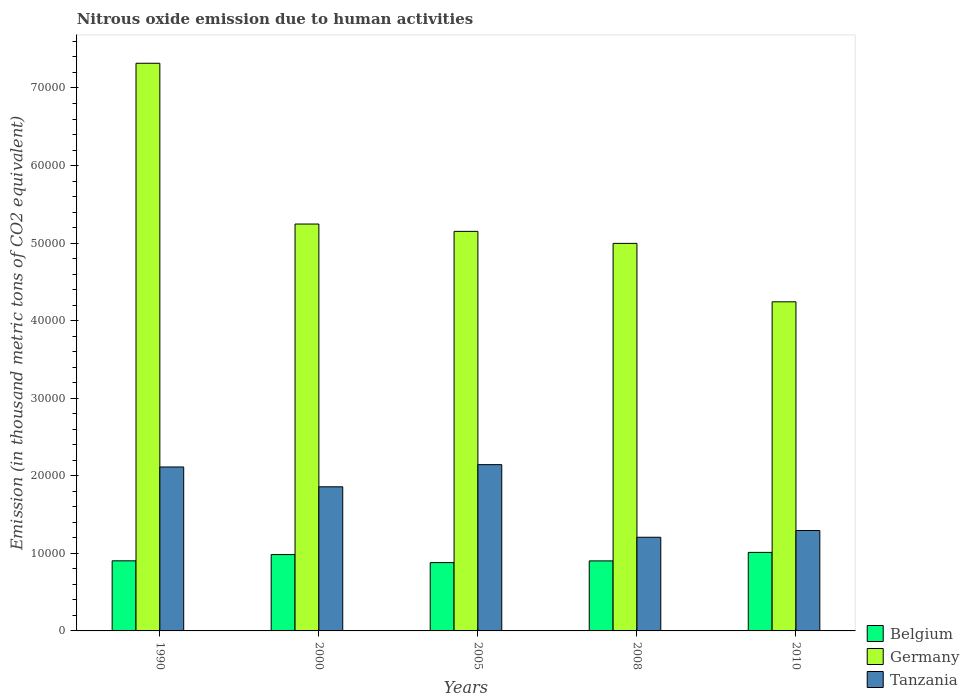How many different coloured bars are there?
Ensure brevity in your answer.  3. How many groups of bars are there?
Make the answer very short. 5. Are the number of bars per tick equal to the number of legend labels?
Give a very brief answer. Yes. Are the number of bars on each tick of the X-axis equal?
Make the answer very short. Yes. How many bars are there on the 3rd tick from the left?
Offer a terse response. 3. How many bars are there on the 2nd tick from the right?
Your answer should be compact. 3. What is the label of the 4th group of bars from the left?
Make the answer very short. 2008. In how many cases, is the number of bars for a given year not equal to the number of legend labels?
Your response must be concise. 0. What is the amount of nitrous oxide emitted in Tanzania in 1990?
Your answer should be very brief. 2.11e+04. Across all years, what is the maximum amount of nitrous oxide emitted in Belgium?
Keep it short and to the point. 1.01e+04. Across all years, what is the minimum amount of nitrous oxide emitted in Belgium?
Give a very brief answer. 8808.6. In which year was the amount of nitrous oxide emitted in Belgium maximum?
Give a very brief answer. 2010. In which year was the amount of nitrous oxide emitted in Germany minimum?
Ensure brevity in your answer.  2010. What is the total amount of nitrous oxide emitted in Germany in the graph?
Offer a terse response. 2.70e+05. What is the difference between the amount of nitrous oxide emitted in Tanzania in 2000 and that in 2008?
Offer a very short reply. 6504.6. What is the difference between the amount of nitrous oxide emitted in Belgium in 2000 and the amount of nitrous oxide emitted in Germany in 2008?
Your answer should be compact. -4.01e+04. What is the average amount of nitrous oxide emitted in Belgium per year?
Keep it short and to the point. 9369.18. In the year 2008, what is the difference between the amount of nitrous oxide emitted in Germany and amount of nitrous oxide emitted in Tanzania?
Your response must be concise. 3.79e+04. In how many years, is the amount of nitrous oxide emitted in Germany greater than 44000 thousand metric tons?
Offer a very short reply. 4. What is the ratio of the amount of nitrous oxide emitted in Tanzania in 2005 to that in 2008?
Provide a short and direct response. 1.78. Is the amount of nitrous oxide emitted in Germany in 1990 less than that in 2005?
Your response must be concise. No. What is the difference between the highest and the second highest amount of nitrous oxide emitted in Germany?
Provide a succinct answer. 2.07e+04. What is the difference between the highest and the lowest amount of nitrous oxide emitted in Tanzania?
Offer a very short reply. 9361.8. In how many years, is the amount of nitrous oxide emitted in Tanzania greater than the average amount of nitrous oxide emitted in Tanzania taken over all years?
Offer a very short reply. 3. Is the sum of the amount of nitrous oxide emitted in Tanzania in 2000 and 2005 greater than the maximum amount of nitrous oxide emitted in Belgium across all years?
Keep it short and to the point. Yes. What does the 1st bar from the right in 2010 represents?
Your answer should be compact. Tanzania. How many bars are there?
Offer a terse response. 15. Are all the bars in the graph horizontal?
Provide a succinct answer. No. How many years are there in the graph?
Offer a terse response. 5. Are the values on the major ticks of Y-axis written in scientific E-notation?
Your response must be concise. No. Where does the legend appear in the graph?
Your answer should be very brief. Bottom right. How many legend labels are there?
Offer a terse response. 3. What is the title of the graph?
Your response must be concise. Nitrous oxide emission due to human activities. Does "Liechtenstein" appear as one of the legend labels in the graph?
Give a very brief answer. No. What is the label or title of the Y-axis?
Your response must be concise. Emission (in thousand metric tons of CO2 equivalent). What is the Emission (in thousand metric tons of CO2 equivalent) of Belgium in 1990?
Keep it short and to the point. 9037.7. What is the Emission (in thousand metric tons of CO2 equivalent) of Germany in 1990?
Keep it short and to the point. 7.32e+04. What is the Emission (in thousand metric tons of CO2 equivalent) in Tanzania in 1990?
Keep it short and to the point. 2.11e+04. What is the Emission (in thousand metric tons of CO2 equivalent) of Belgium in 2000?
Offer a very short reply. 9844.1. What is the Emission (in thousand metric tons of CO2 equivalent) in Germany in 2000?
Ensure brevity in your answer.  5.25e+04. What is the Emission (in thousand metric tons of CO2 equivalent) of Tanzania in 2000?
Offer a very short reply. 1.86e+04. What is the Emission (in thousand metric tons of CO2 equivalent) in Belgium in 2005?
Keep it short and to the point. 8808.6. What is the Emission (in thousand metric tons of CO2 equivalent) in Germany in 2005?
Make the answer very short. 5.15e+04. What is the Emission (in thousand metric tons of CO2 equivalent) of Tanzania in 2005?
Keep it short and to the point. 2.14e+04. What is the Emission (in thousand metric tons of CO2 equivalent) in Belgium in 2008?
Offer a very short reply. 9028.7. What is the Emission (in thousand metric tons of CO2 equivalent) of Germany in 2008?
Give a very brief answer. 5.00e+04. What is the Emission (in thousand metric tons of CO2 equivalent) of Tanzania in 2008?
Make the answer very short. 1.21e+04. What is the Emission (in thousand metric tons of CO2 equivalent) in Belgium in 2010?
Give a very brief answer. 1.01e+04. What is the Emission (in thousand metric tons of CO2 equivalent) of Germany in 2010?
Keep it short and to the point. 4.24e+04. What is the Emission (in thousand metric tons of CO2 equivalent) of Tanzania in 2010?
Your answer should be compact. 1.29e+04. Across all years, what is the maximum Emission (in thousand metric tons of CO2 equivalent) of Belgium?
Ensure brevity in your answer.  1.01e+04. Across all years, what is the maximum Emission (in thousand metric tons of CO2 equivalent) in Germany?
Ensure brevity in your answer.  7.32e+04. Across all years, what is the maximum Emission (in thousand metric tons of CO2 equivalent) of Tanzania?
Offer a very short reply. 2.14e+04. Across all years, what is the minimum Emission (in thousand metric tons of CO2 equivalent) of Belgium?
Your answer should be very brief. 8808.6. Across all years, what is the minimum Emission (in thousand metric tons of CO2 equivalent) of Germany?
Your answer should be very brief. 4.24e+04. Across all years, what is the minimum Emission (in thousand metric tons of CO2 equivalent) in Tanzania?
Keep it short and to the point. 1.21e+04. What is the total Emission (in thousand metric tons of CO2 equivalent) of Belgium in the graph?
Your answer should be very brief. 4.68e+04. What is the total Emission (in thousand metric tons of CO2 equivalent) of Germany in the graph?
Your answer should be compact. 2.70e+05. What is the total Emission (in thousand metric tons of CO2 equivalent) in Tanzania in the graph?
Your response must be concise. 8.62e+04. What is the difference between the Emission (in thousand metric tons of CO2 equivalent) in Belgium in 1990 and that in 2000?
Your answer should be compact. -806.4. What is the difference between the Emission (in thousand metric tons of CO2 equivalent) in Germany in 1990 and that in 2000?
Your answer should be compact. 2.07e+04. What is the difference between the Emission (in thousand metric tons of CO2 equivalent) of Tanzania in 1990 and that in 2000?
Your answer should be very brief. 2557. What is the difference between the Emission (in thousand metric tons of CO2 equivalent) in Belgium in 1990 and that in 2005?
Offer a very short reply. 229.1. What is the difference between the Emission (in thousand metric tons of CO2 equivalent) of Germany in 1990 and that in 2005?
Offer a very short reply. 2.17e+04. What is the difference between the Emission (in thousand metric tons of CO2 equivalent) in Tanzania in 1990 and that in 2005?
Your answer should be compact. -300.2. What is the difference between the Emission (in thousand metric tons of CO2 equivalent) in Belgium in 1990 and that in 2008?
Make the answer very short. 9. What is the difference between the Emission (in thousand metric tons of CO2 equivalent) in Germany in 1990 and that in 2008?
Give a very brief answer. 2.32e+04. What is the difference between the Emission (in thousand metric tons of CO2 equivalent) in Tanzania in 1990 and that in 2008?
Provide a short and direct response. 9061.6. What is the difference between the Emission (in thousand metric tons of CO2 equivalent) in Belgium in 1990 and that in 2010?
Provide a short and direct response. -1089.1. What is the difference between the Emission (in thousand metric tons of CO2 equivalent) in Germany in 1990 and that in 2010?
Give a very brief answer. 3.08e+04. What is the difference between the Emission (in thousand metric tons of CO2 equivalent) of Tanzania in 1990 and that in 2010?
Your answer should be compact. 8189.7. What is the difference between the Emission (in thousand metric tons of CO2 equivalent) in Belgium in 2000 and that in 2005?
Provide a succinct answer. 1035.5. What is the difference between the Emission (in thousand metric tons of CO2 equivalent) in Germany in 2000 and that in 2005?
Provide a succinct answer. 945.2. What is the difference between the Emission (in thousand metric tons of CO2 equivalent) of Tanzania in 2000 and that in 2005?
Ensure brevity in your answer.  -2857.2. What is the difference between the Emission (in thousand metric tons of CO2 equivalent) in Belgium in 2000 and that in 2008?
Your answer should be very brief. 815.4. What is the difference between the Emission (in thousand metric tons of CO2 equivalent) of Germany in 2000 and that in 2008?
Offer a very short reply. 2493.2. What is the difference between the Emission (in thousand metric tons of CO2 equivalent) of Tanzania in 2000 and that in 2008?
Your answer should be compact. 6504.6. What is the difference between the Emission (in thousand metric tons of CO2 equivalent) in Belgium in 2000 and that in 2010?
Provide a short and direct response. -282.7. What is the difference between the Emission (in thousand metric tons of CO2 equivalent) in Germany in 2000 and that in 2010?
Your answer should be very brief. 1.00e+04. What is the difference between the Emission (in thousand metric tons of CO2 equivalent) in Tanzania in 2000 and that in 2010?
Offer a terse response. 5632.7. What is the difference between the Emission (in thousand metric tons of CO2 equivalent) in Belgium in 2005 and that in 2008?
Offer a terse response. -220.1. What is the difference between the Emission (in thousand metric tons of CO2 equivalent) in Germany in 2005 and that in 2008?
Provide a succinct answer. 1548. What is the difference between the Emission (in thousand metric tons of CO2 equivalent) of Tanzania in 2005 and that in 2008?
Give a very brief answer. 9361.8. What is the difference between the Emission (in thousand metric tons of CO2 equivalent) of Belgium in 2005 and that in 2010?
Your answer should be very brief. -1318.2. What is the difference between the Emission (in thousand metric tons of CO2 equivalent) of Germany in 2005 and that in 2010?
Offer a terse response. 9081.9. What is the difference between the Emission (in thousand metric tons of CO2 equivalent) in Tanzania in 2005 and that in 2010?
Provide a short and direct response. 8489.9. What is the difference between the Emission (in thousand metric tons of CO2 equivalent) in Belgium in 2008 and that in 2010?
Offer a terse response. -1098.1. What is the difference between the Emission (in thousand metric tons of CO2 equivalent) of Germany in 2008 and that in 2010?
Ensure brevity in your answer.  7533.9. What is the difference between the Emission (in thousand metric tons of CO2 equivalent) in Tanzania in 2008 and that in 2010?
Provide a succinct answer. -871.9. What is the difference between the Emission (in thousand metric tons of CO2 equivalent) in Belgium in 1990 and the Emission (in thousand metric tons of CO2 equivalent) in Germany in 2000?
Keep it short and to the point. -4.34e+04. What is the difference between the Emission (in thousand metric tons of CO2 equivalent) of Belgium in 1990 and the Emission (in thousand metric tons of CO2 equivalent) of Tanzania in 2000?
Ensure brevity in your answer.  -9542.5. What is the difference between the Emission (in thousand metric tons of CO2 equivalent) in Germany in 1990 and the Emission (in thousand metric tons of CO2 equivalent) in Tanzania in 2000?
Keep it short and to the point. 5.46e+04. What is the difference between the Emission (in thousand metric tons of CO2 equivalent) of Belgium in 1990 and the Emission (in thousand metric tons of CO2 equivalent) of Germany in 2005?
Offer a terse response. -4.25e+04. What is the difference between the Emission (in thousand metric tons of CO2 equivalent) of Belgium in 1990 and the Emission (in thousand metric tons of CO2 equivalent) of Tanzania in 2005?
Ensure brevity in your answer.  -1.24e+04. What is the difference between the Emission (in thousand metric tons of CO2 equivalent) of Germany in 1990 and the Emission (in thousand metric tons of CO2 equivalent) of Tanzania in 2005?
Offer a very short reply. 5.18e+04. What is the difference between the Emission (in thousand metric tons of CO2 equivalent) of Belgium in 1990 and the Emission (in thousand metric tons of CO2 equivalent) of Germany in 2008?
Offer a terse response. -4.09e+04. What is the difference between the Emission (in thousand metric tons of CO2 equivalent) in Belgium in 1990 and the Emission (in thousand metric tons of CO2 equivalent) in Tanzania in 2008?
Your answer should be very brief. -3037.9. What is the difference between the Emission (in thousand metric tons of CO2 equivalent) of Germany in 1990 and the Emission (in thousand metric tons of CO2 equivalent) of Tanzania in 2008?
Offer a very short reply. 6.11e+04. What is the difference between the Emission (in thousand metric tons of CO2 equivalent) of Belgium in 1990 and the Emission (in thousand metric tons of CO2 equivalent) of Germany in 2010?
Your response must be concise. -3.34e+04. What is the difference between the Emission (in thousand metric tons of CO2 equivalent) of Belgium in 1990 and the Emission (in thousand metric tons of CO2 equivalent) of Tanzania in 2010?
Ensure brevity in your answer.  -3909.8. What is the difference between the Emission (in thousand metric tons of CO2 equivalent) in Germany in 1990 and the Emission (in thousand metric tons of CO2 equivalent) in Tanzania in 2010?
Ensure brevity in your answer.  6.02e+04. What is the difference between the Emission (in thousand metric tons of CO2 equivalent) in Belgium in 2000 and the Emission (in thousand metric tons of CO2 equivalent) in Germany in 2005?
Your answer should be compact. -4.17e+04. What is the difference between the Emission (in thousand metric tons of CO2 equivalent) in Belgium in 2000 and the Emission (in thousand metric tons of CO2 equivalent) in Tanzania in 2005?
Provide a short and direct response. -1.16e+04. What is the difference between the Emission (in thousand metric tons of CO2 equivalent) in Germany in 2000 and the Emission (in thousand metric tons of CO2 equivalent) in Tanzania in 2005?
Your answer should be compact. 3.10e+04. What is the difference between the Emission (in thousand metric tons of CO2 equivalent) of Belgium in 2000 and the Emission (in thousand metric tons of CO2 equivalent) of Germany in 2008?
Your answer should be very brief. -4.01e+04. What is the difference between the Emission (in thousand metric tons of CO2 equivalent) of Belgium in 2000 and the Emission (in thousand metric tons of CO2 equivalent) of Tanzania in 2008?
Your response must be concise. -2231.5. What is the difference between the Emission (in thousand metric tons of CO2 equivalent) of Germany in 2000 and the Emission (in thousand metric tons of CO2 equivalent) of Tanzania in 2008?
Your answer should be compact. 4.04e+04. What is the difference between the Emission (in thousand metric tons of CO2 equivalent) of Belgium in 2000 and the Emission (in thousand metric tons of CO2 equivalent) of Germany in 2010?
Keep it short and to the point. -3.26e+04. What is the difference between the Emission (in thousand metric tons of CO2 equivalent) in Belgium in 2000 and the Emission (in thousand metric tons of CO2 equivalent) in Tanzania in 2010?
Offer a terse response. -3103.4. What is the difference between the Emission (in thousand metric tons of CO2 equivalent) of Germany in 2000 and the Emission (in thousand metric tons of CO2 equivalent) of Tanzania in 2010?
Offer a very short reply. 3.95e+04. What is the difference between the Emission (in thousand metric tons of CO2 equivalent) in Belgium in 2005 and the Emission (in thousand metric tons of CO2 equivalent) in Germany in 2008?
Keep it short and to the point. -4.12e+04. What is the difference between the Emission (in thousand metric tons of CO2 equivalent) in Belgium in 2005 and the Emission (in thousand metric tons of CO2 equivalent) in Tanzania in 2008?
Make the answer very short. -3267. What is the difference between the Emission (in thousand metric tons of CO2 equivalent) in Germany in 2005 and the Emission (in thousand metric tons of CO2 equivalent) in Tanzania in 2008?
Provide a succinct answer. 3.94e+04. What is the difference between the Emission (in thousand metric tons of CO2 equivalent) of Belgium in 2005 and the Emission (in thousand metric tons of CO2 equivalent) of Germany in 2010?
Provide a short and direct response. -3.36e+04. What is the difference between the Emission (in thousand metric tons of CO2 equivalent) in Belgium in 2005 and the Emission (in thousand metric tons of CO2 equivalent) in Tanzania in 2010?
Provide a short and direct response. -4138.9. What is the difference between the Emission (in thousand metric tons of CO2 equivalent) in Germany in 2005 and the Emission (in thousand metric tons of CO2 equivalent) in Tanzania in 2010?
Give a very brief answer. 3.86e+04. What is the difference between the Emission (in thousand metric tons of CO2 equivalent) of Belgium in 2008 and the Emission (in thousand metric tons of CO2 equivalent) of Germany in 2010?
Your response must be concise. -3.34e+04. What is the difference between the Emission (in thousand metric tons of CO2 equivalent) in Belgium in 2008 and the Emission (in thousand metric tons of CO2 equivalent) in Tanzania in 2010?
Your response must be concise. -3918.8. What is the difference between the Emission (in thousand metric tons of CO2 equivalent) of Germany in 2008 and the Emission (in thousand metric tons of CO2 equivalent) of Tanzania in 2010?
Provide a short and direct response. 3.70e+04. What is the average Emission (in thousand metric tons of CO2 equivalent) in Belgium per year?
Give a very brief answer. 9369.18. What is the average Emission (in thousand metric tons of CO2 equivalent) of Germany per year?
Your response must be concise. 5.39e+04. What is the average Emission (in thousand metric tons of CO2 equivalent) of Tanzania per year?
Make the answer very short. 1.72e+04. In the year 1990, what is the difference between the Emission (in thousand metric tons of CO2 equivalent) in Belgium and Emission (in thousand metric tons of CO2 equivalent) in Germany?
Keep it short and to the point. -6.42e+04. In the year 1990, what is the difference between the Emission (in thousand metric tons of CO2 equivalent) of Belgium and Emission (in thousand metric tons of CO2 equivalent) of Tanzania?
Offer a very short reply. -1.21e+04. In the year 1990, what is the difference between the Emission (in thousand metric tons of CO2 equivalent) of Germany and Emission (in thousand metric tons of CO2 equivalent) of Tanzania?
Offer a terse response. 5.21e+04. In the year 2000, what is the difference between the Emission (in thousand metric tons of CO2 equivalent) in Belgium and Emission (in thousand metric tons of CO2 equivalent) in Germany?
Offer a terse response. -4.26e+04. In the year 2000, what is the difference between the Emission (in thousand metric tons of CO2 equivalent) of Belgium and Emission (in thousand metric tons of CO2 equivalent) of Tanzania?
Provide a short and direct response. -8736.1. In the year 2000, what is the difference between the Emission (in thousand metric tons of CO2 equivalent) of Germany and Emission (in thousand metric tons of CO2 equivalent) of Tanzania?
Ensure brevity in your answer.  3.39e+04. In the year 2005, what is the difference between the Emission (in thousand metric tons of CO2 equivalent) of Belgium and Emission (in thousand metric tons of CO2 equivalent) of Germany?
Give a very brief answer. -4.27e+04. In the year 2005, what is the difference between the Emission (in thousand metric tons of CO2 equivalent) of Belgium and Emission (in thousand metric tons of CO2 equivalent) of Tanzania?
Your answer should be compact. -1.26e+04. In the year 2005, what is the difference between the Emission (in thousand metric tons of CO2 equivalent) in Germany and Emission (in thousand metric tons of CO2 equivalent) in Tanzania?
Give a very brief answer. 3.01e+04. In the year 2008, what is the difference between the Emission (in thousand metric tons of CO2 equivalent) of Belgium and Emission (in thousand metric tons of CO2 equivalent) of Germany?
Make the answer very short. -4.09e+04. In the year 2008, what is the difference between the Emission (in thousand metric tons of CO2 equivalent) in Belgium and Emission (in thousand metric tons of CO2 equivalent) in Tanzania?
Offer a very short reply. -3046.9. In the year 2008, what is the difference between the Emission (in thousand metric tons of CO2 equivalent) of Germany and Emission (in thousand metric tons of CO2 equivalent) of Tanzania?
Make the answer very short. 3.79e+04. In the year 2010, what is the difference between the Emission (in thousand metric tons of CO2 equivalent) in Belgium and Emission (in thousand metric tons of CO2 equivalent) in Germany?
Give a very brief answer. -3.23e+04. In the year 2010, what is the difference between the Emission (in thousand metric tons of CO2 equivalent) in Belgium and Emission (in thousand metric tons of CO2 equivalent) in Tanzania?
Your response must be concise. -2820.7. In the year 2010, what is the difference between the Emission (in thousand metric tons of CO2 equivalent) in Germany and Emission (in thousand metric tons of CO2 equivalent) in Tanzania?
Your answer should be very brief. 2.95e+04. What is the ratio of the Emission (in thousand metric tons of CO2 equivalent) in Belgium in 1990 to that in 2000?
Ensure brevity in your answer.  0.92. What is the ratio of the Emission (in thousand metric tons of CO2 equivalent) of Germany in 1990 to that in 2000?
Provide a succinct answer. 1.4. What is the ratio of the Emission (in thousand metric tons of CO2 equivalent) in Tanzania in 1990 to that in 2000?
Ensure brevity in your answer.  1.14. What is the ratio of the Emission (in thousand metric tons of CO2 equivalent) of Germany in 1990 to that in 2005?
Make the answer very short. 1.42. What is the ratio of the Emission (in thousand metric tons of CO2 equivalent) in Tanzania in 1990 to that in 2005?
Give a very brief answer. 0.99. What is the ratio of the Emission (in thousand metric tons of CO2 equivalent) of Belgium in 1990 to that in 2008?
Your response must be concise. 1. What is the ratio of the Emission (in thousand metric tons of CO2 equivalent) of Germany in 1990 to that in 2008?
Ensure brevity in your answer.  1.46. What is the ratio of the Emission (in thousand metric tons of CO2 equivalent) in Tanzania in 1990 to that in 2008?
Give a very brief answer. 1.75. What is the ratio of the Emission (in thousand metric tons of CO2 equivalent) in Belgium in 1990 to that in 2010?
Your answer should be compact. 0.89. What is the ratio of the Emission (in thousand metric tons of CO2 equivalent) of Germany in 1990 to that in 2010?
Keep it short and to the point. 1.72. What is the ratio of the Emission (in thousand metric tons of CO2 equivalent) of Tanzania in 1990 to that in 2010?
Your answer should be very brief. 1.63. What is the ratio of the Emission (in thousand metric tons of CO2 equivalent) of Belgium in 2000 to that in 2005?
Provide a succinct answer. 1.12. What is the ratio of the Emission (in thousand metric tons of CO2 equivalent) of Germany in 2000 to that in 2005?
Your answer should be very brief. 1.02. What is the ratio of the Emission (in thousand metric tons of CO2 equivalent) in Tanzania in 2000 to that in 2005?
Make the answer very short. 0.87. What is the ratio of the Emission (in thousand metric tons of CO2 equivalent) in Belgium in 2000 to that in 2008?
Your answer should be very brief. 1.09. What is the ratio of the Emission (in thousand metric tons of CO2 equivalent) in Germany in 2000 to that in 2008?
Give a very brief answer. 1.05. What is the ratio of the Emission (in thousand metric tons of CO2 equivalent) of Tanzania in 2000 to that in 2008?
Your answer should be very brief. 1.54. What is the ratio of the Emission (in thousand metric tons of CO2 equivalent) of Belgium in 2000 to that in 2010?
Keep it short and to the point. 0.97. What is the ratio of the Emission (in thousand metric tons of CO2 equivalent) of Germany in 2000 to that in 2010?
Your answer should be compact. 1.24. What is the ratio of the Emission (in thousand metric tons of CO2 equivalent) of Tanzania in 2000 to that in 2010?
Offer a terse response. 1.44. What is the ratio of the Emission (in thousand metric tons of CO2 equivalent) of Belgium in 2005 to that in 2008?
Provide a short and direct response. 0.98. What is the ratio of the Emission (in thousand metric tons of CO2 equivalent) of Germany in 2005 to that in 2008?
Offer a terse response. 1.03. What is the ratio of the Emission (in thousand metric tons of CO2 equivalent) in Tanzania in 2005 to that in 2008?
Provide a short and direct response. 1.78. What is the ratio of the Emission (in thousand metric tons of CO2 equivalent) in Belgium in 2005 to that in 2010?
Provide a succinct answer. 0.87. What is the ratio of the Emission (in thousand metric tons of CO2 equivalent) of Germany in 2005 to that in 2010?
Give a very brief answer. 1.21. What is the ratio of the Emission (in thousand metric tons of CO2 equivalent) in Tanzania in 2005 to that in 2010?
Your response must be concise. 1.66. What is the ratio of the Emission (in thousand metric tons of CO2 equivalent) of Belgium in 2008 to that in 2010?
Your answer should be compact. 0.89. What is the ratio of the Emission (in thousand metric tons of CO2 equivalent) in Germany in 2008 to that in 2010?
Offer a very short reply. 1.18. What is the ratio of the Emission (in thousand metric tons of CO2 equivalent) in Tanzania in 2008 to that in 2010?
Offer a very short reply. 0.93. What is the difference between the highest and the second highest Emission (in thousand metric tons of CO2 equivalent) of Belgium?
Provide a short and direct response. 282.7. What is the difference between the highest and the second highest Emission (in thousand metric tons of CO2 equivalent) of Germany?
Your response must be concise. 2.07e+04. What is the difference between the highest and the second highest Emission (in thousand metric tons of CO2 equivalent) in Tanzania?
Ensure brevity in your answer.  300.2. What is the difference between the highest and the lowest Emission (in thousand metric tons of CO2 equivalent) in Belgium?
Your answer should be very brief. 1318.2. What is the difference between the highest and the lowest Emission (in thousand metric tons of CO2 equivalent) of Germany?
Provide a short and direct response. 3.08e+04. What is the difference between the highest and the lowest Emission (in thousand metric tons of CO2 equivalent) in Tanzania?
Ensure brevity in your answer.  9361.8. 